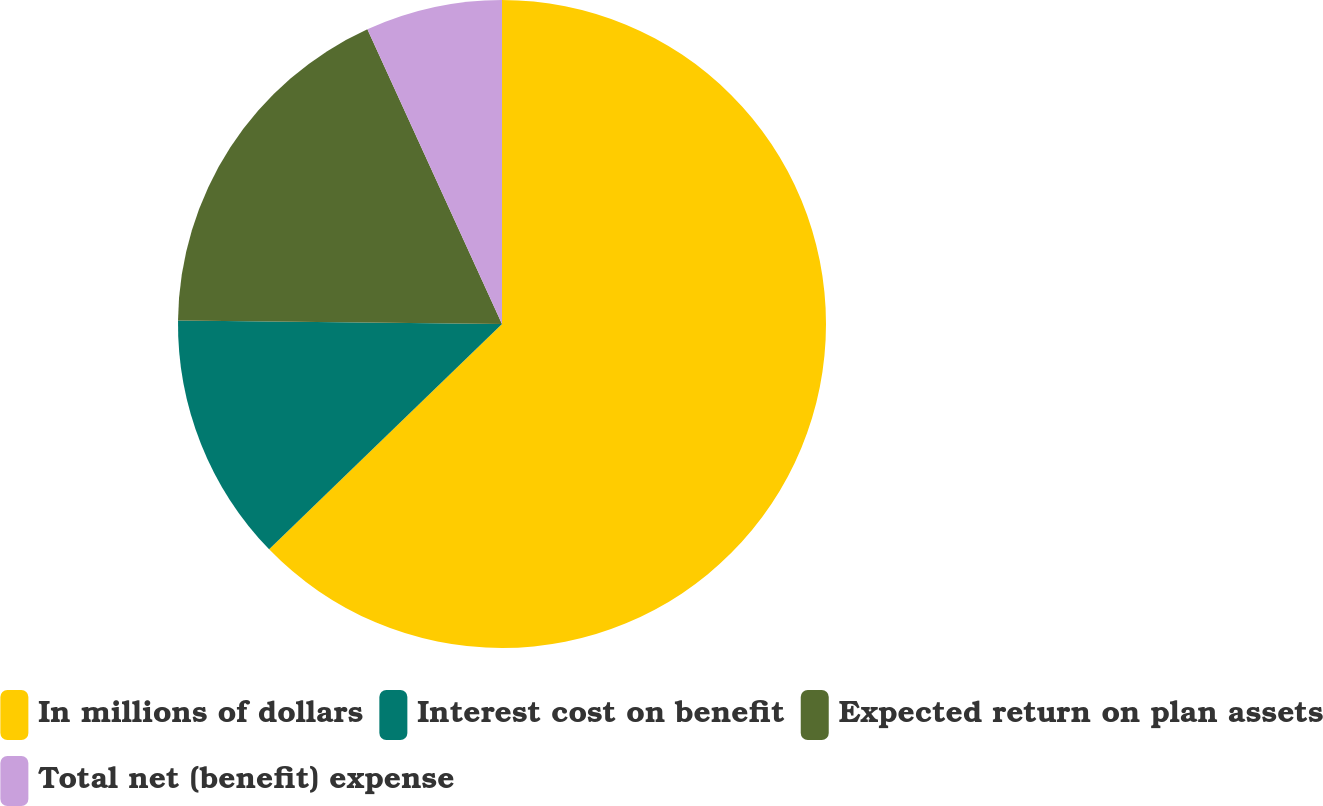<chart> <loc_0><loc_0><loc_500><loc_500><pie_chart><fcel>In millions of dollars<fcel>Interest cost on benefit<fcel>Expected return on plan assets<fcel>Total net (benefit) expense<nl><fcel>62.77%<fcel>12.41%<fcel>18.01%<fcel>6.82%<nl></chart> 